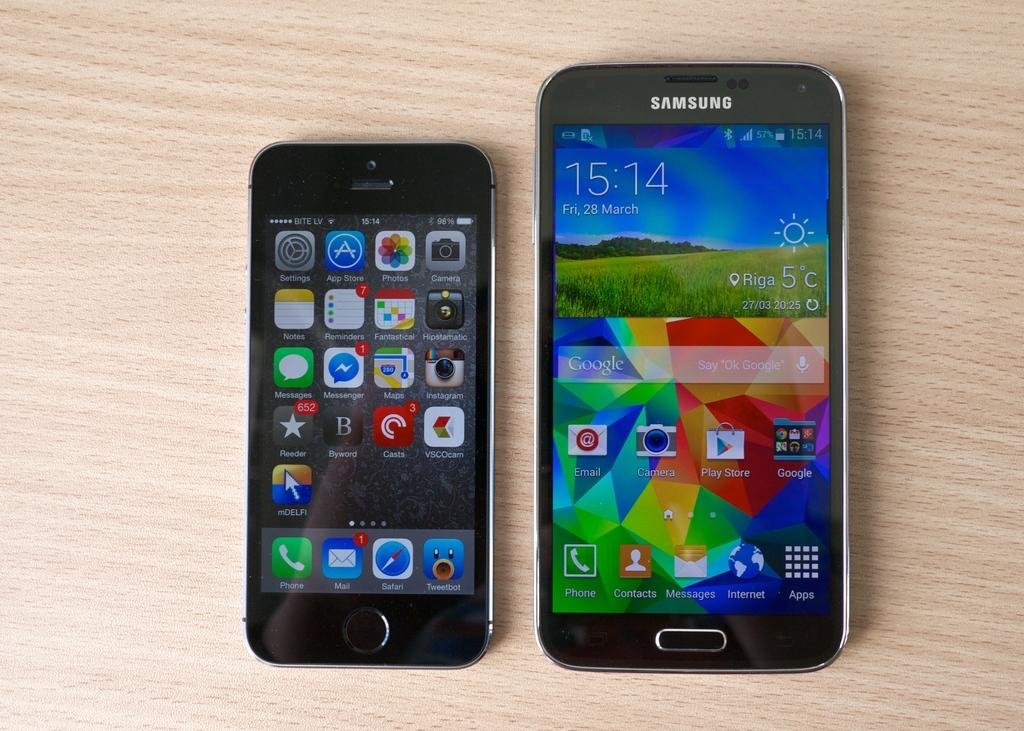<image>
Create a compact narrative representing the image presented. An Apple iPhone sits on a table to the left of a phone that has Samsung written on the top of it. 